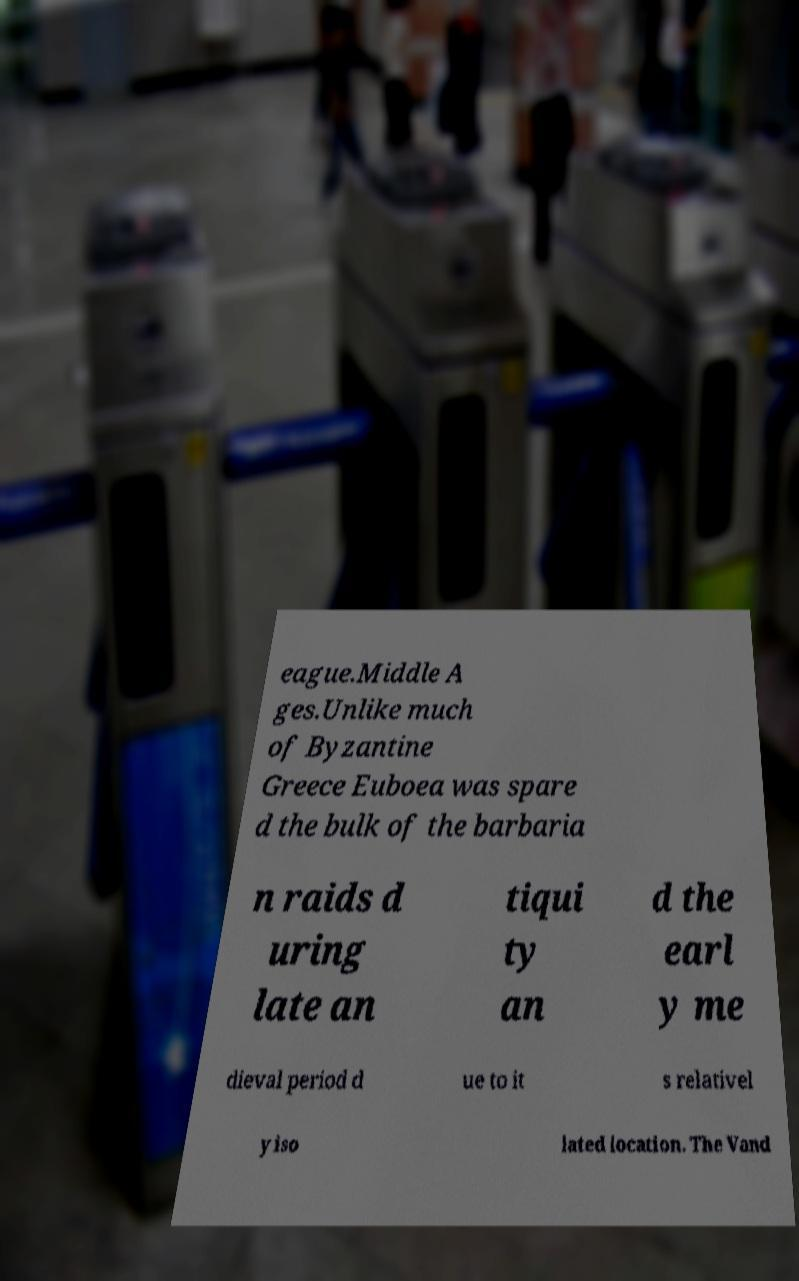There's text embedded in this image that I need extracted. Can you transcribe it verbatim? eague.Middle A ges.Unlike much of Byzantine Greece Euboea was spare d the bulk of the barbaria n raids d uring late an tiqui ty an d the earl y me dieval period d ue to it s relativel y iso lated location. The Vand 